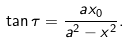<formula> <loc_0><loc_0><loc_500><loc_500>\tan \tau = \frac { a x _ { 0 } } { a ^ { 2 } - x ^ { 2 } } .</formula> 